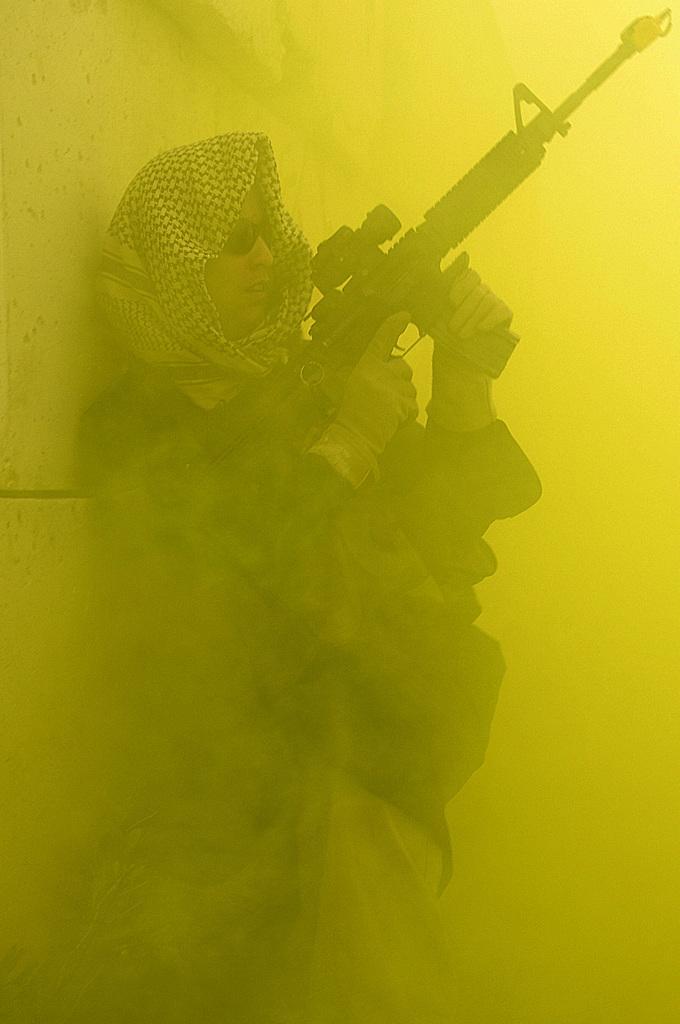Can you describe this image briefly? The man in the middle of the picture wearing a black jacket and white and black scarf is holding a gun in his hand and he is even wearing spectacles. Behind him, we see a wall in yellow color and in the background, it is yellow in color. 